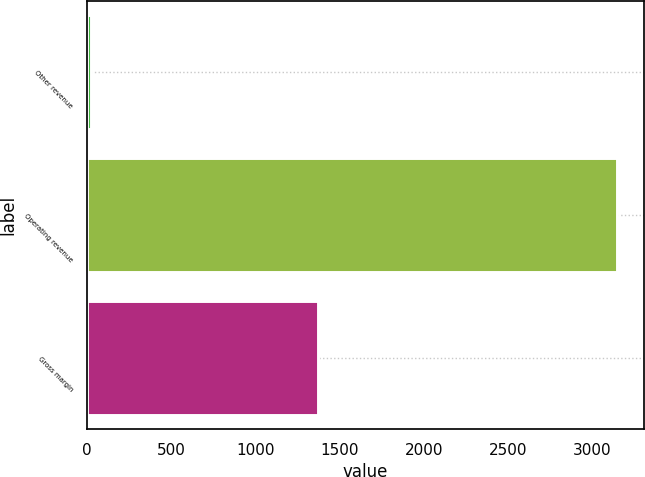Convert chart to OTSL. <chart><loc_0><loc_0><loc_500><loc_500><bar_chart><fcel>Other revenue<fcel>Operating revenue<fcel>Gross margin<nl><fcel>26<fcel>3149<fcel>1373<nl></chart> 